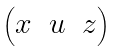<formula> <loc_0><loc_0><loc_500><loc_500>\begin{pmatrix} x & u & z \end{pmatrix}</formula> 